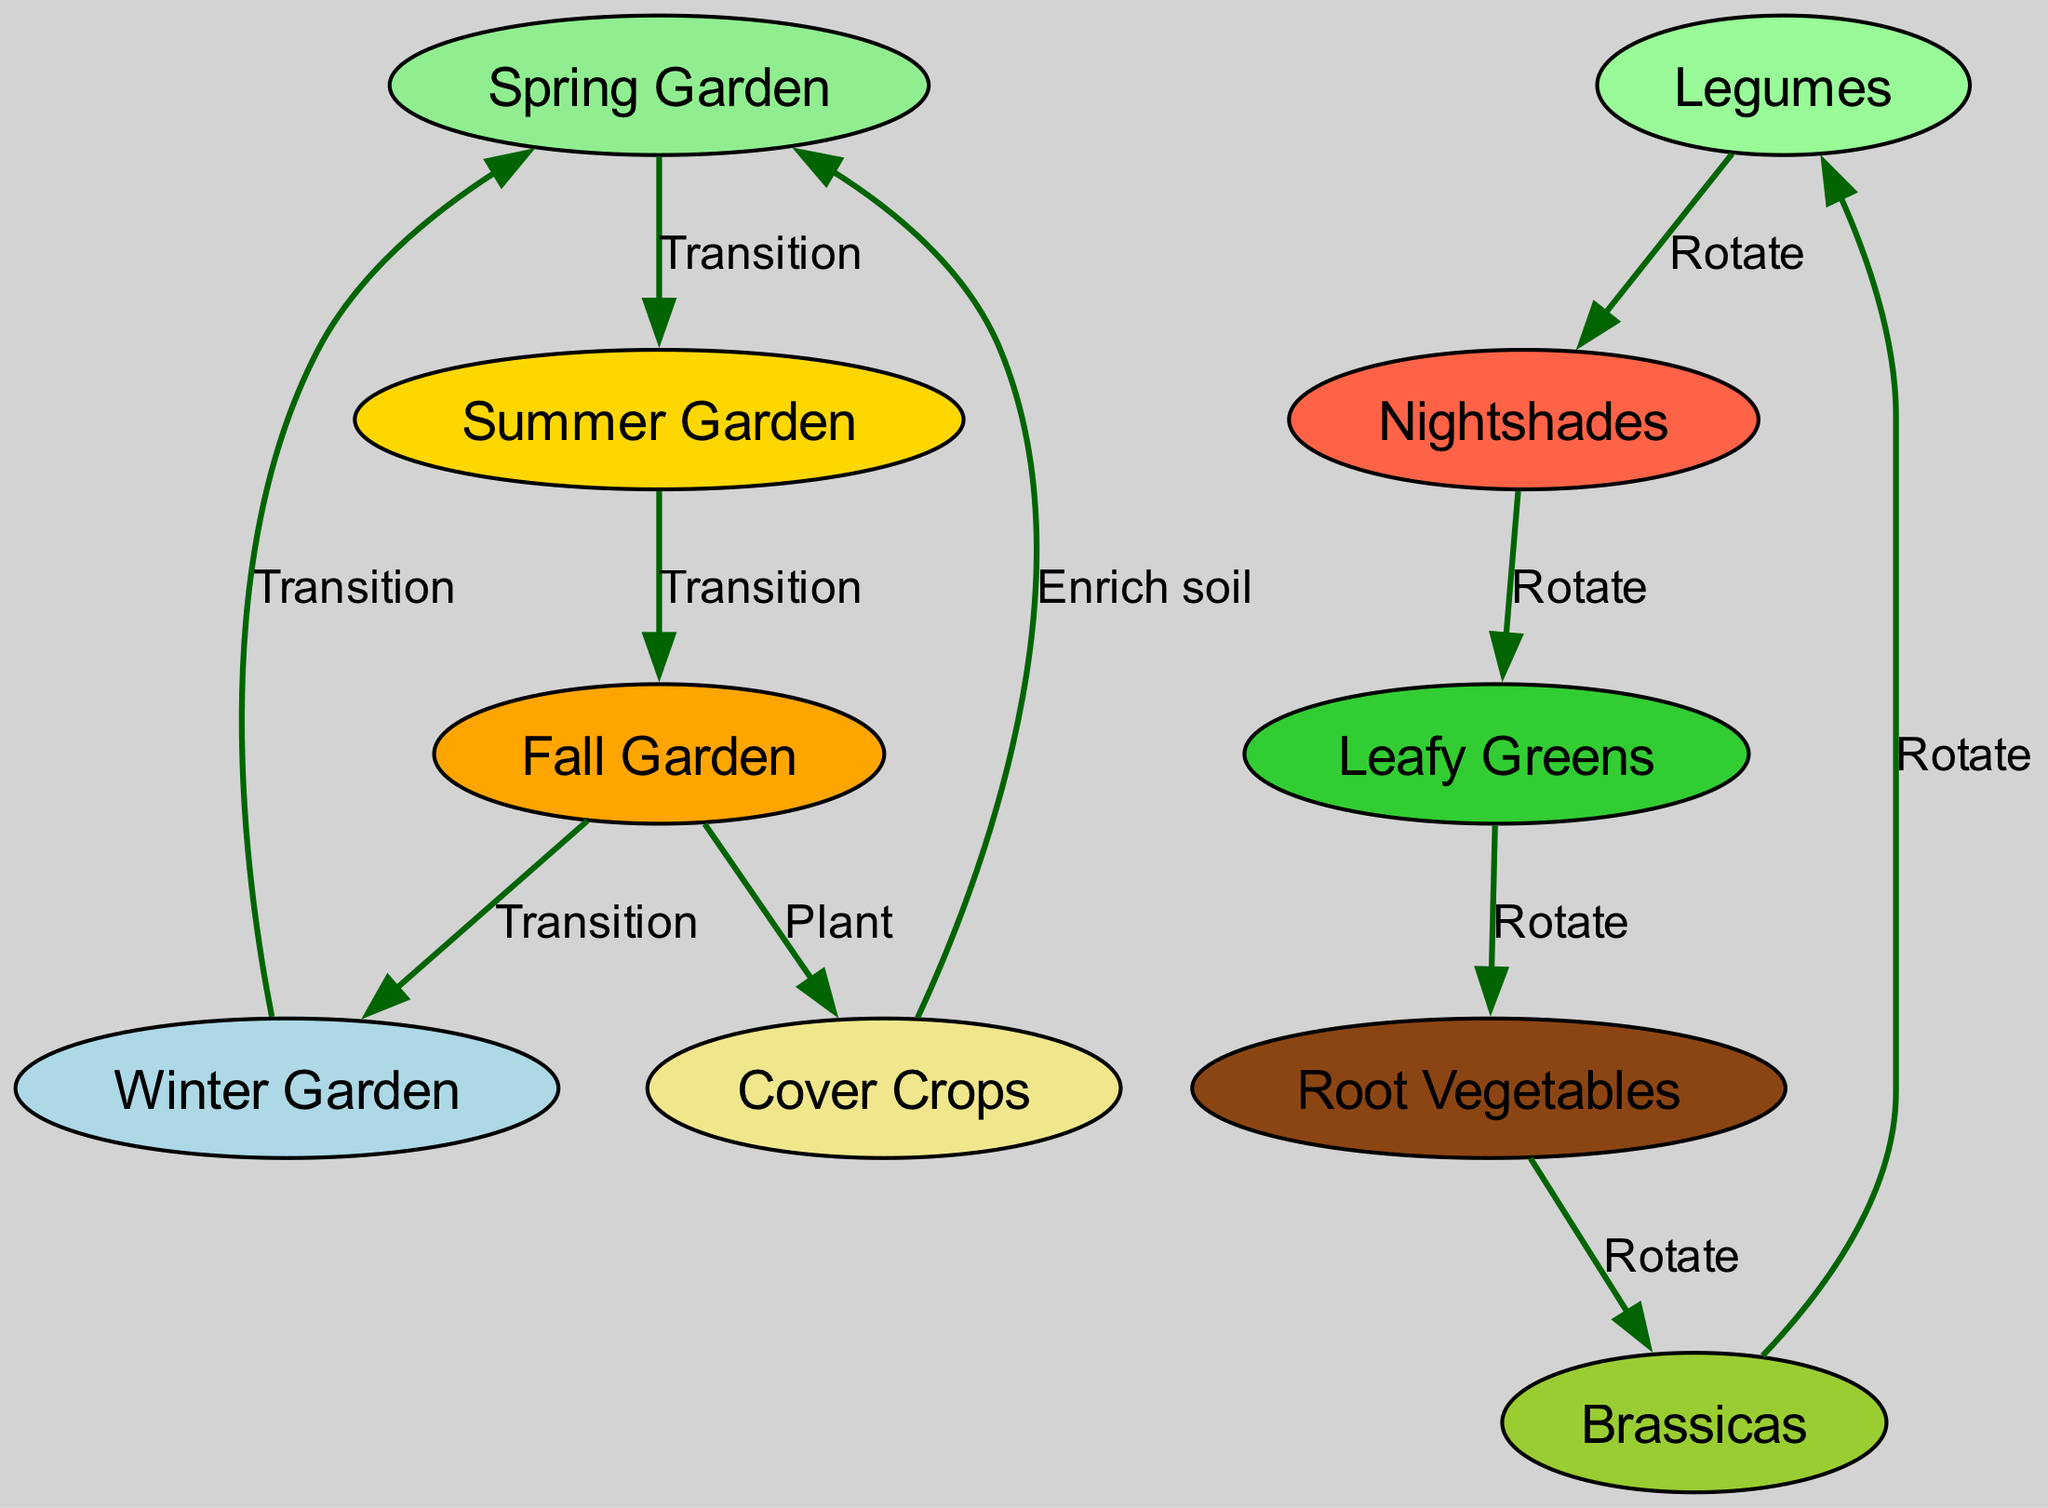What is the starting garden for the crop rotation? According to the diagram, the first garden in the rotation is the Spring Garden, as indicated by its position at the top and the flow directing to the Summer Garden afterward.
Answer: Spring Garden How many nodes are in the diagram? Counting the nodes listed in the data, we see there are 10 distinct nodes representing different gardens and types of crops.
Answer: 10 Which crop rotates after Leafy Greens? The diagram shows that after Leafy Greens, the crop that follows in the rotation is Root Vegetables, depicted by the edge leading from Leafy Greens to Root Vegetables.
Answer: Root Vegetables What is the purpose of planting Cover Crops in the Fall Garden? The diagram indicates that planting Cover Crops in the Fall Garden serves to enrich the soil, as labeled by the edge transitioning from Fall Garden to Cover Crops.
Answer: Enrich soil What is the final crop to rotate back to before returning to the Legumes? Following the edges in the diagram, we observe that the rotation sequence concludes with Brassicas, which then links back to Legumes to complete the cycle.
Answer: Brassicas Which season follows the Summer Garden? The directed flow in the diagram clearly indicates that after the Summer Garden, the next garden in the rotation is the Fall Garden, as shown by the edge transitioning between these two nodes.
Answer: Fall Garden How many transitions occur between the gardens? By counting the directed edges that connect the seasonal gardens in the diagram, we find there are a total of 4 transitions from Spring to Summer, Summer to Fall, Fall to Winter, and Winter back to Spring.
Answer: 4 What type of vegetables should follow Nightshades? The crop rotation in the diagram specifies that following Nightshades in the sequence comes Leafy Greens, indicated by the directed edge leading to this node.
Answer: Leafy Greens Which garden is planted after the Fall Garden? The diagram shows that after the Fall Garden, the next step is to plant Cover Crops, as represented by the directed edge coming from the Fall Garden to this node.
Answer: Cover Crops 